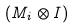<formula> <loc_0><loc_0><loc_500><loc_500>( M _ { i } \otimes I )</formula> 